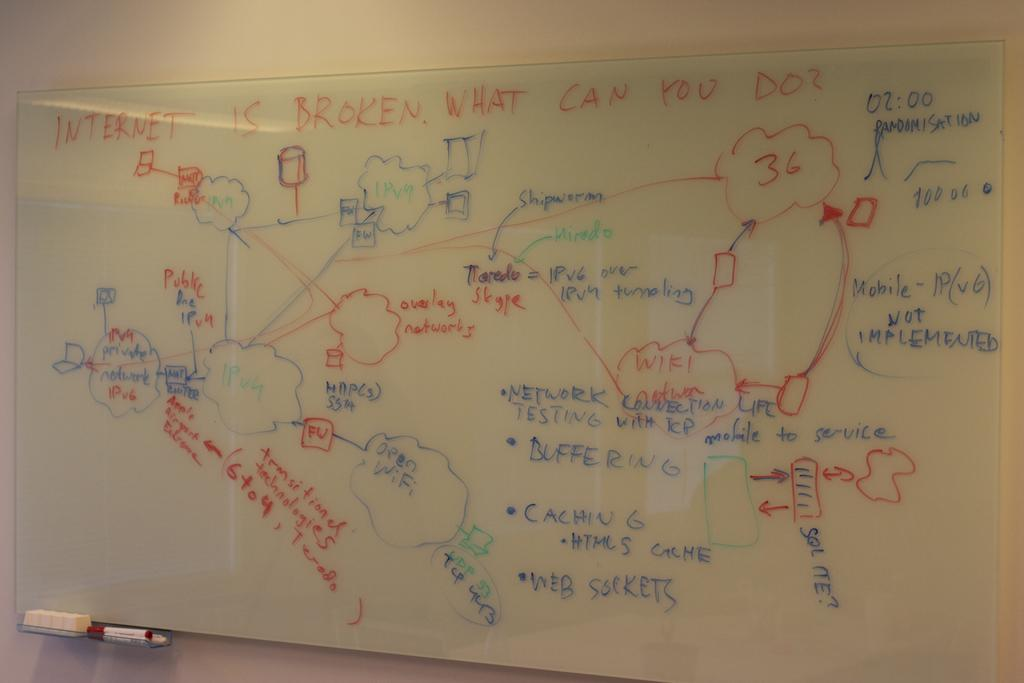<image>
Create a compact narrative representing the image presented. A complicated diagram provides several solutions to internet connectivity problems. 